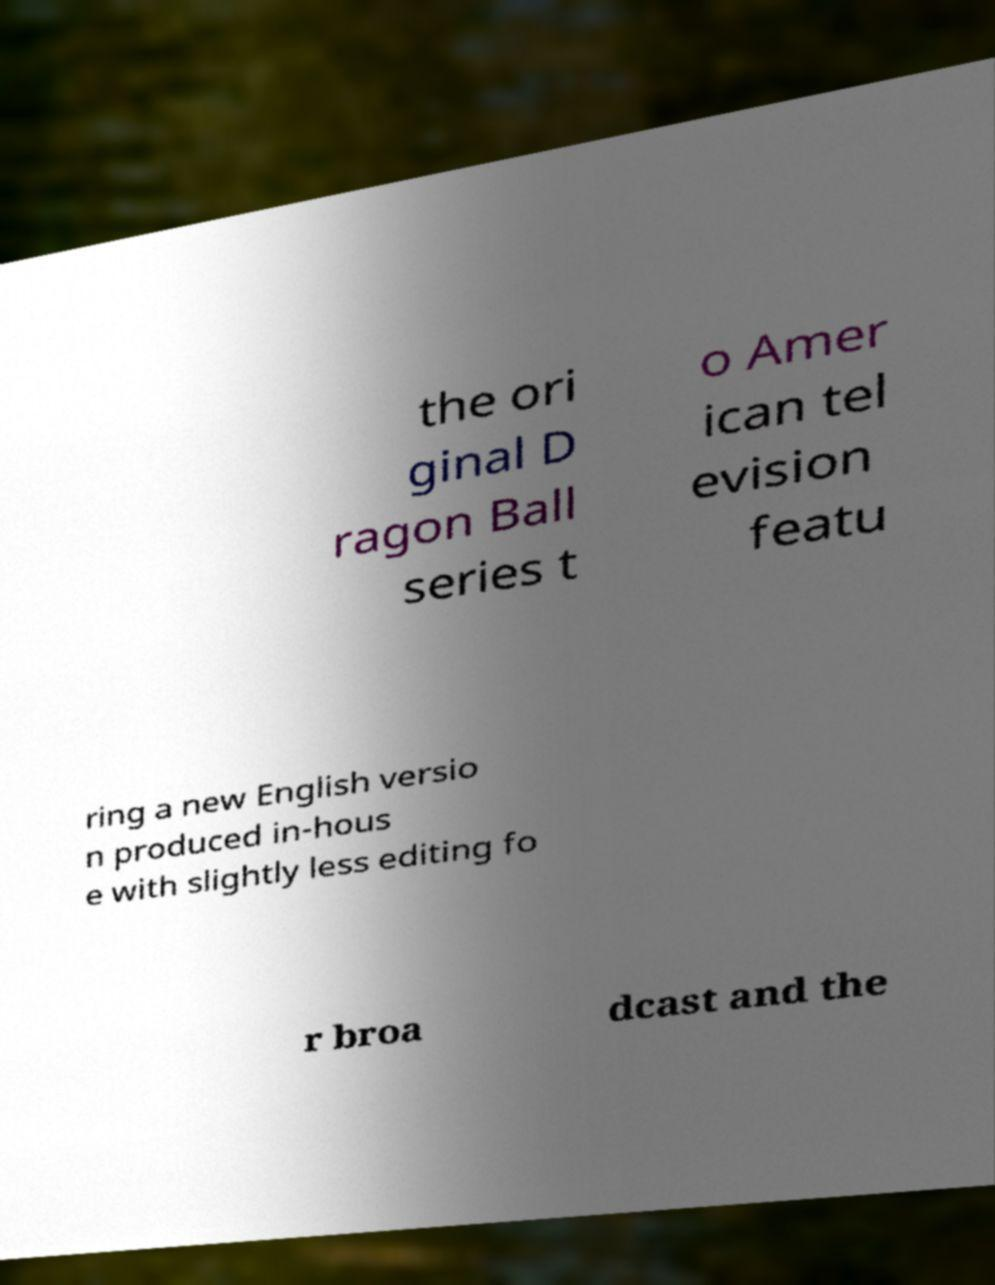What messages or text are displayed in this image? I need them in a readable, typed format. the ori ginal D ragon Ball series t o Amer ican tel evision featu ring a new English versio n produced in-hous e with slightly less editing fo r broa dcast and the 